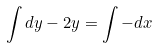Convert formula to latex. <formula><loc_0><loc_0><loc_500><loc_500>\int d y - 2 y = \int - d x</formula> 